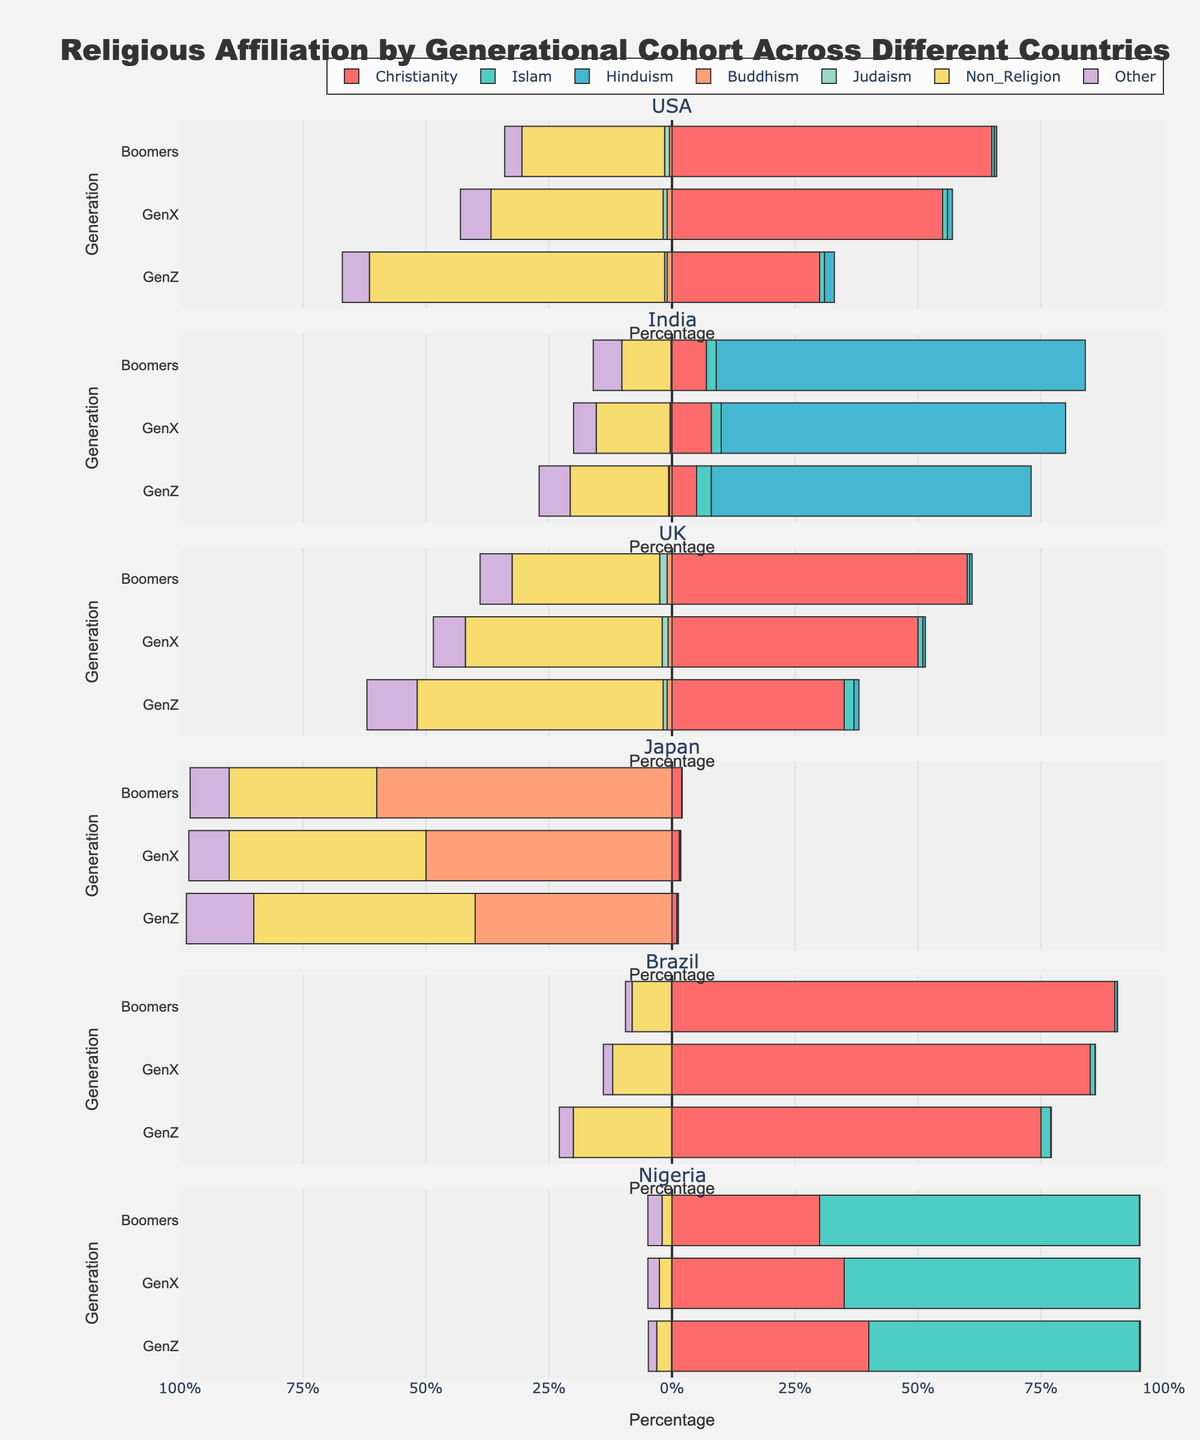What's the dominant religion for Boomers in the USA? Look at the bar chart for Boomers in the USA. Identify which religion has the highest percentage.
Answer: Christianity What percentage of GenZ in the UK identifies as Non-Religious? Locate the GenZ bar for the UK. Check the color representing Non_Religion and see the corresponding percentage.
Answer: 50% Which generation in India has the highest percentage of people identifying as Hindu? Compare the bars for each generation in India. Identify which bar segment labeled Hindu is the longest.
Answer: Boomers Are there more Christians or Non-Religious individuals in GenX in the UK? Compare the length of the bars representing Christianity and Non_Religion for GenX in the UK.
Answer: Christians What is the sum of individuals in Japan identifying as Buddhism and Non-Religion across all generations shown? Calculate the sum of the percentages for Buddhism and Non_Religion across GenZ, GenX, and Boomers in Japan: 40+50+60 for Buddhism and 45+40+30 for Non-Religion. Add them up: 40+50+60+45+40+30.
Answer: 265% Does Nigeria feature more Christians or Muslims across all generations? Examine the length of the bars representing Christianity and Islam in Nigeria for GenZ, GenX, and Boomers. Compare their total lengths.
Answer: Muslims How does the percentage of Christians in GenZ in Brazil compare to Boomers? Measure the length of the bar segment for Christianity in both GenZ and Boomers in Brazil. Compare the two percentages.
Answer: GenZ has 75%, Boomers have 90% Which generation in the USA has the largest proportion of Non-Religious individuals? Compare the length of the Non_Religion bar segment for each generation in the USA.
Answer: GenZ Compare the percentage of Jews between GenZ in the UK and GenX in Japan. Identify the percentage of Judaism for GenZ in the UK and GenX in Japan and see which is larger and by how much.
Answer: GenZ in the UK: 0.8%, GenX in Japan: 0.01%. GenZ in the UK has 0.79% more Which generation in Brazil sees the smallest percentage of individuals associated with "Other" religions? Check the bar chart segment labeled "Other" for all generations in Brazil and see which is the smallest.
Answer: Boomers 